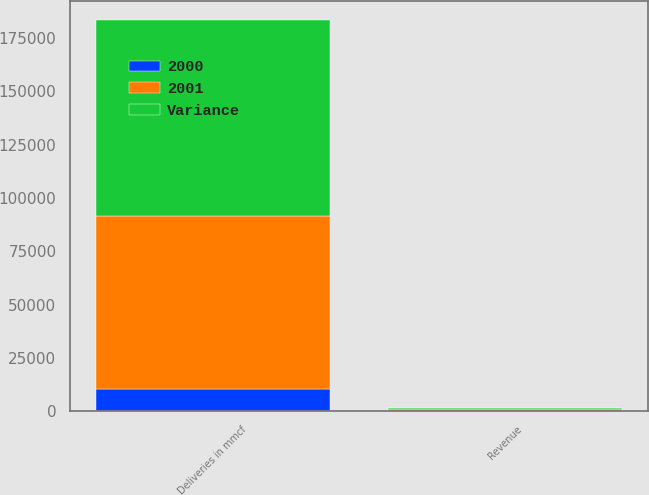<chart> <loc_0><loc_0><loc_500><loc_500><stacked_bar_chart><ecel><fcel>Deliveries in mmcf<fcel>Revenue<nl><fcel>2001<fcel>81528<fcel>654<nl><fcel>Variance<fcel>91686<fcel>532<nl><fcel>2000<fcel>10158<fcel>122<nl></chart> 